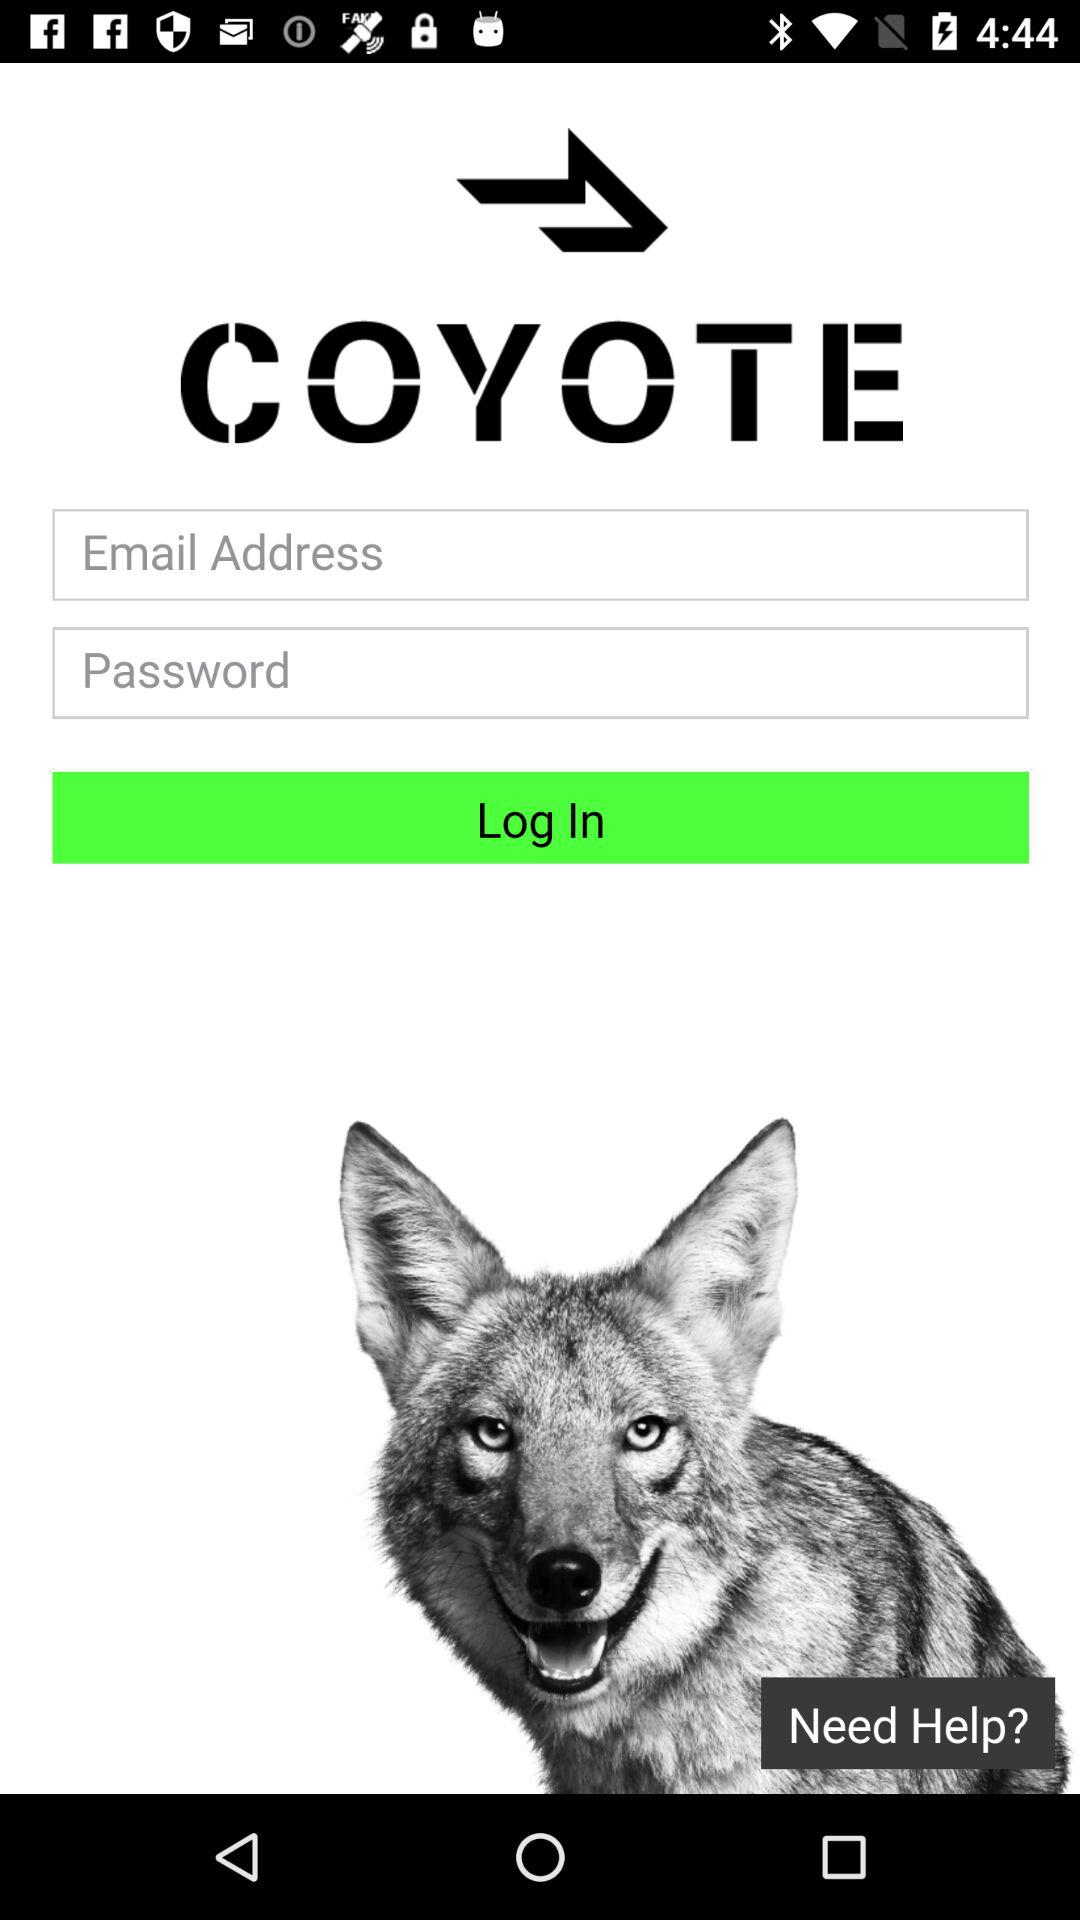What is the application name? The application name is "COYOTE". 